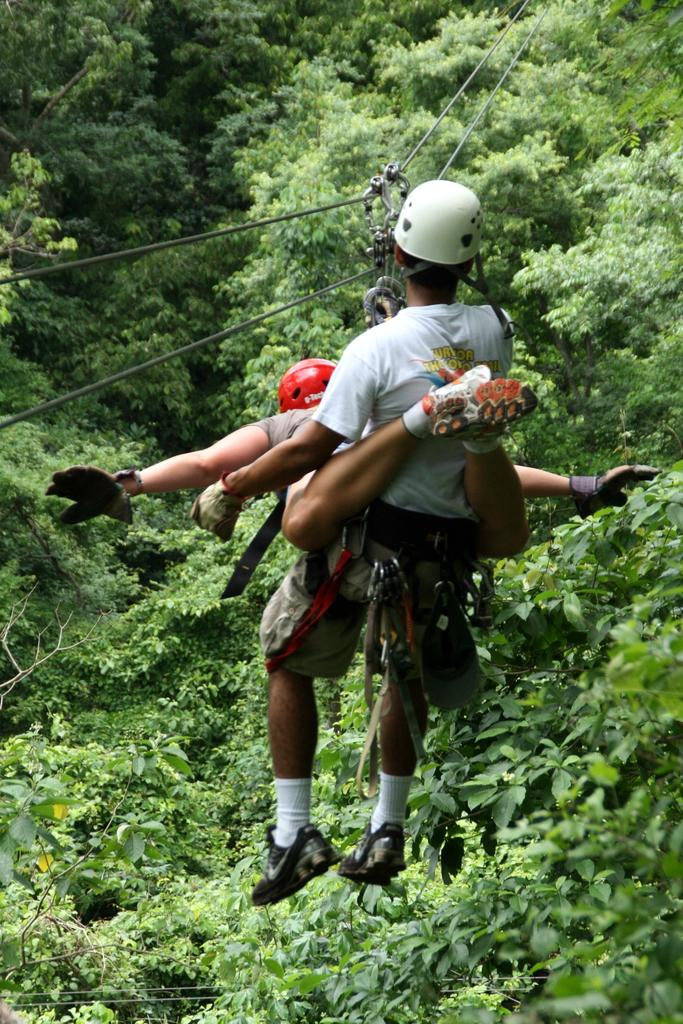Where was the image taken? The image is clicked outside the city. How many people are in the foreground of the image? There are two persons in the foreground of the image. What are the persons wearing on their heads? The persons are wearing helmets. What are the persons doing in the image? The persons are hanging on a cable. What can be seen in the background of the image? There are trees visible in the background of the image. What type of plantation can be seen in the image? There is no plantation visible in the image; it features two persons hanging on a cable outside the city. Is the grandfather in the image taking a picture of the scene? There is no mention of a grandfather or a camera in the image, so it cannot be determined if someone is taking a picture. 